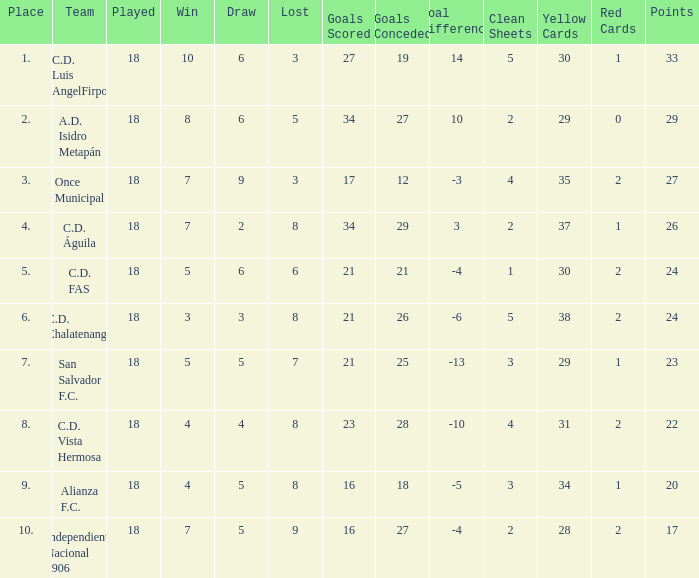For Once Municipal, what were the goals scored that had less than 27 points and greater than place 1? None. 